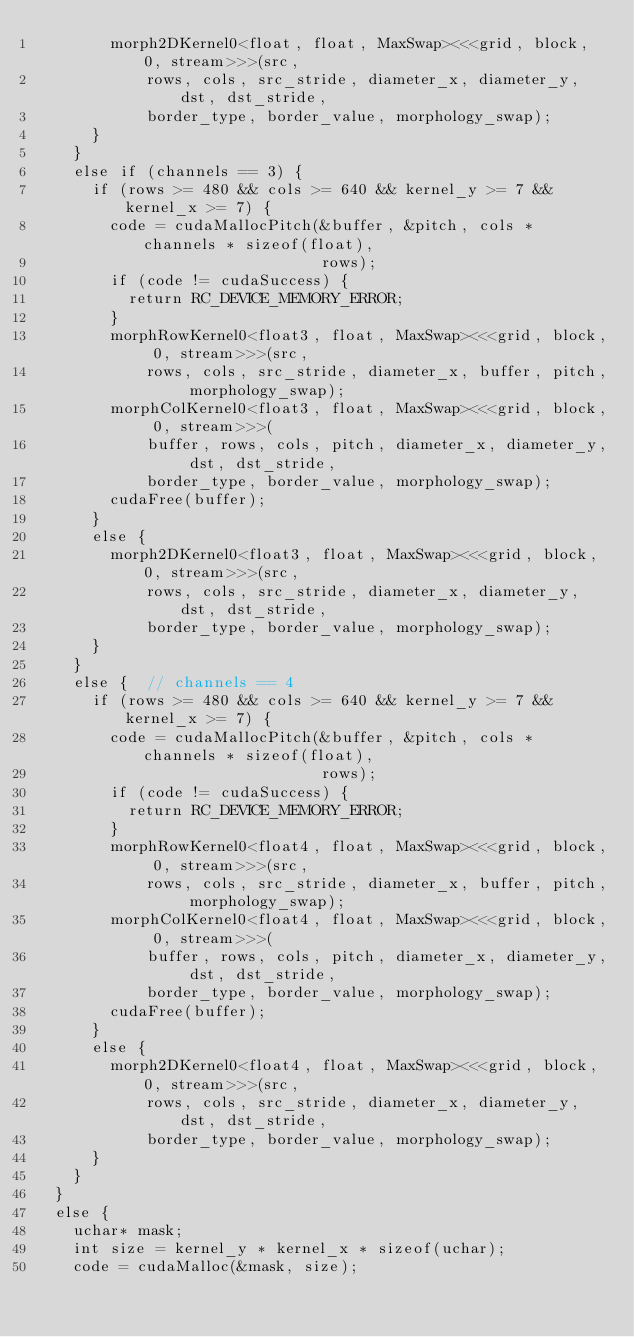Convert code to text. <code><loc_0><loc_0><loc_500><loc_500><_Cuda_>        morph2DKernel0<float, float, MaxSwap><<<grid, block, 0, stream>>>(src,
            rows, cols, src_stride, diameter_x, diameter_y, dst, dst_stride,
            border_type, border_value, morphology_swap);
      }
    }
    else if (channels == 3) {
      if (rows >= 480 && cols >= 640 && kernel_y >= 7 && kernel_x >= 7) {
        code = cudaMallocPitch(&buffer, &pitch, cols * channels * sizeof(float),
                               rows);
        if (code != cudaSuccess) {
          return RC_DEVICE_MEMORY_ERROR;
        }
        morphRowKernel0<float3, float, MaxSwap><<<grid, block, 0, stream>>>(src,
            rows, cols, src_stride, diameter_x, buffer, pitch, morphology_swap);
        morphColKernel0<float3, float, MaxSwap><<<grid, block, 0, stream>>>(
            buffer, rows, cols, pitch, diameter_x, diameter_y, dst, dst_stride,
            border_type, border_value, morphology_swap);
        cudaFree(buffer);
      }
      else {
        morph2DKernel0<float3, float, MaxSwap><<<grid, block, 0, stream>>>(src,
            rows, cols, src_stride, diameter_x, diameter_y, dst, dst_stride,
            border_type, border_value, morphology_swap);
      }
    }
    else {  // channels == 4
      if (rows >= 480 && cols >= 640 && kernel_y >= 7 && kernel_x >= 7) {
        code = cudaMallocPitch(&buffer, &pitch, cols * channels * sizeof(float),
                               rows);
        if (code != cudaSuccess) {
          return RC_DEVICE_MEMORY_ERROR;
        }
        morphRowKernel0<float4, float, MaxSwap><<<grid, block, 0, stream>>>(src,
            rows, cols, src_stride, diameter_x, buffer, pitch, morphology_swap);
        morphColKernel0<float4, float, MaxSwap><<<grid, block, 0, stream>>>(
            buffer, rows, cols, pitch, diameter_x, diameter_y, dst, dst_stride,
            border_type, border_value, morphology_swap);
        cudaFree(buffer);
      }
      else {
        morph2DKernel0<float4, float, MaxSwap><<<grid, block, 0, stream>>>(src,
            rows, cols, src_stride, diameter_x, diameter_y, dst, dst_stride,
            border_type, border_value, morphology_swap);
      }
    }
  }
  else {
    uchar* mask;
    int size = kernel_y * kernel_x * sizeof(uchar);
    code = cudaMalloc(&mask, size);</code> 